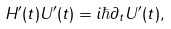Convert formula to latex. <formula><loc_0><loc_0><loc_500><loc_500>H ^ { \prime } ( t ) U ^ { \prime } ( t ) = i \hbar { \partial } _ { t } U ^ { \prime } ( t ) ,</formula> 